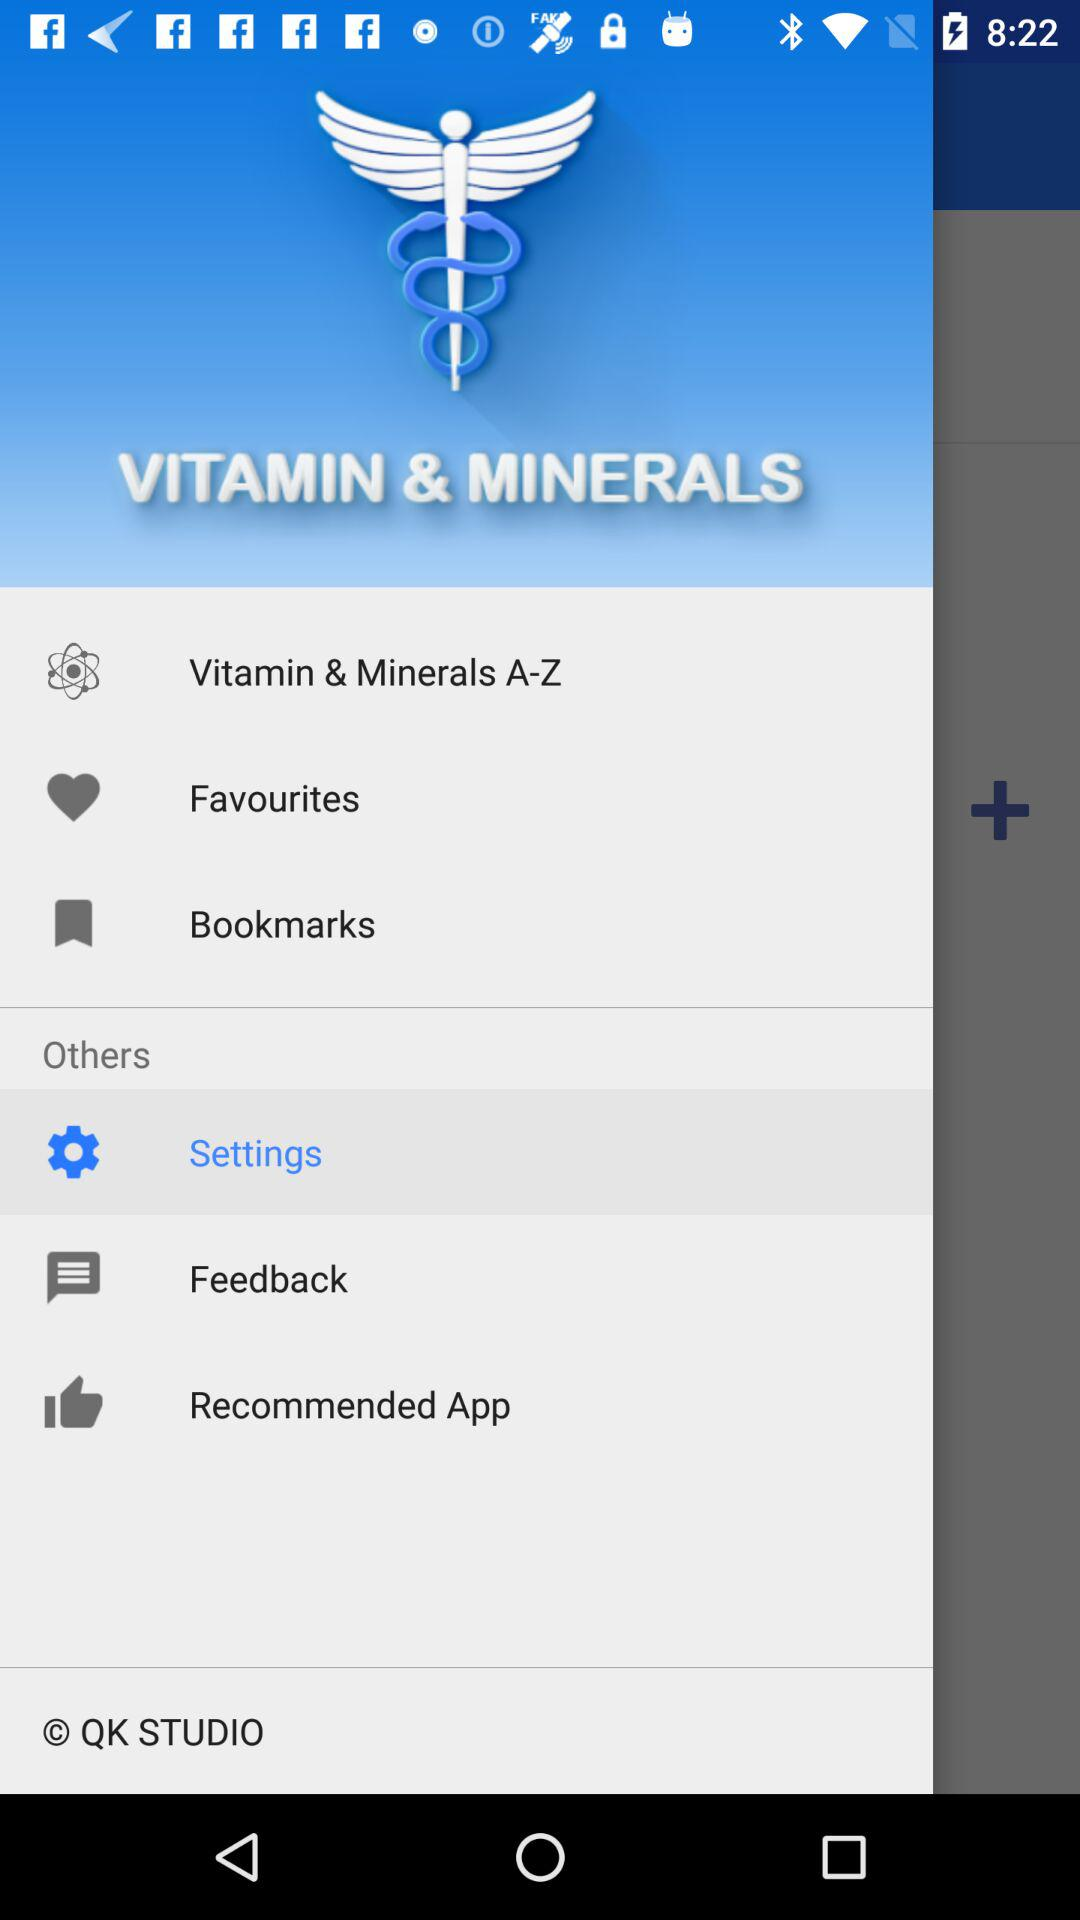What is the name of the application? The name of the application is "VITAMIN & MINERALS". 